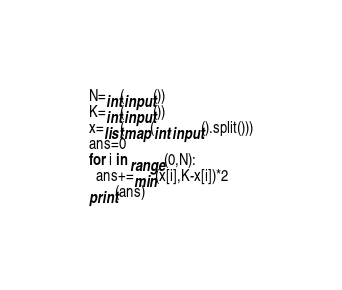Convert code to text. <code><loc_0><loc_0><loc_500><loc_500><_Python_>N=int(input())
K=int(input())
x=list(map(int,input().split()))
ans=0
for i in range(0,N):
  ans+=min(x[i],K-x[i])*2
print(ans)
</code> 